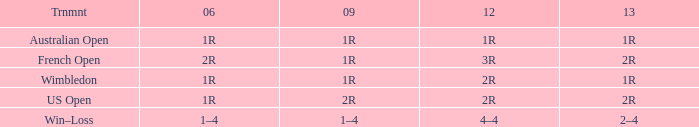What is the Tournament when the 2013 is 2r, and a 2006 is 1r? US Open. 